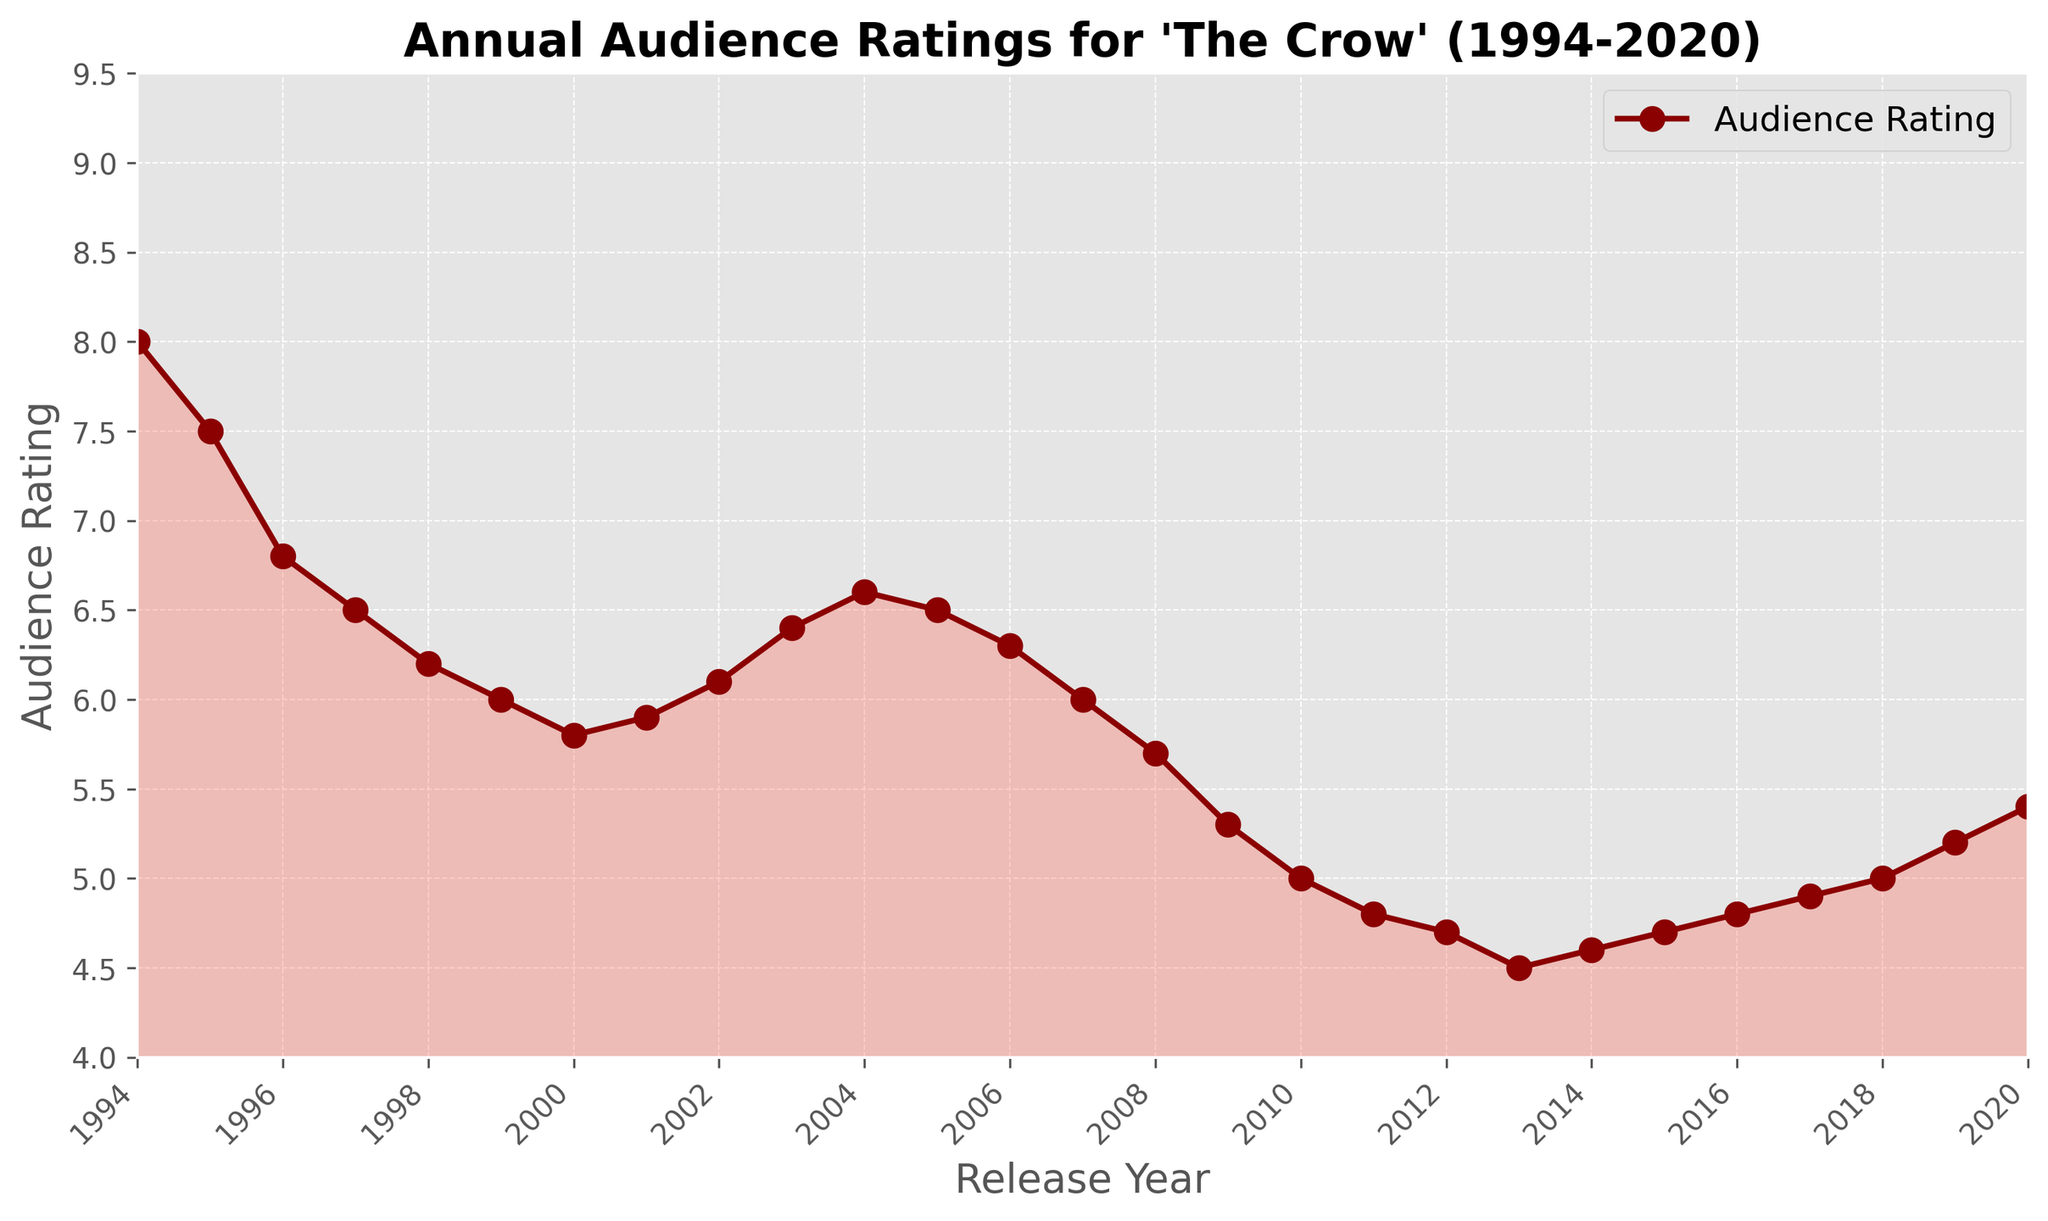What is the highest audience rating in the given period? The highest rating can be identified by looking at the peak of the line chart. The peak corresponds to the year 1994 with an audience rating of 8.0.
Answer: 8.0 Between which years did the audience rating experience the steepest decline? The steepest decline can be identified by looking for the part of the line chart with the sharpest downward slope. This occurs between 1994 and 1995, where the rating drops from 8.0 to 7.5.
Answer: 1994 to 1995 What is the overall trend of the audience ratings from 1994 to 2020? The overall trend can be assessed by observing the general direction of the line chart. The ratings show a downward trend from 1994 to around 2013, followed by a slight recovery from 2014 onwards.
Answer: Downward, then slight recovery How does the audience rating in 2020 compare with the rating in 2010? Compare the points at 2020 and 2010 by looking at where they intersect the y-axis. In 2010, the rating is 5.0, while in 2020, the rating is 5.4. Therefore, there is an increase in the rating.
Answer: 2020 is higher by 0.4 What is the average rating between 2001 and 2005? To find the average, sum the ratings from 2001 to 2005 and divide by 5. The ratings are: 5.9, 6.1, 6.4, 6.6, and 6.5. Total sum: 31.5. Average: 31.5 / 5.
Answer: 6.3 Are there any years where the rating remained the same as the previous year? Check for flat segments on the chart. This occurs between 2004 and 2005, where the rating remains at 6.5.
Answer: Yes, 2004 to 2005 Which period had a more stable audience rating, 1994-2000 or 2010-2020? Compare the variability within each period. From 1994 to 2000, the rating declines from 8.0 to 5.8 with more fluctuations. From 2010 to 2020, the rating varies more narrowly from 5.0 to 5.4.
Answer: 2010-2020 What year had the lowest audience rating? Identify the lowest point on the chart, which occurs in 2013 with an audience rating of 4.5.
Answer: 2013 How many years did the audience rating increase consecutively between 1994 and 2020? Look for continuous upward segments of the line chart. From 2013 to 2020, the ratings increase consecutively from 4.5 to 5.4 over 7 years.
Answer: 7 years 